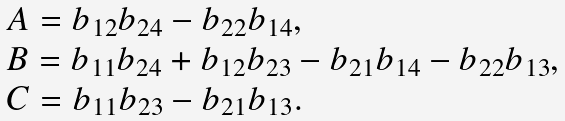<formula> <loc_0><loc_0><loc_500><loc_500>\begin{array} { l } A = b _ { 1 2 } b _ { 2 4 } - b _ { 2 2 } b _ { 1 4 } , \\ B = b _ { 1 1 } b _ { 2 4 } + b _ { 1 2 } b _ { 2 3 } - b _ { 2 1 } b _ { 1 4 } - b _ { 2 2 } b _ { 1 3 } , \\ C = b _ { 1 1 } b _ { 2 3 } - b _ { 2 1 } b _ { 1 3 } . \end{array}</formula> 